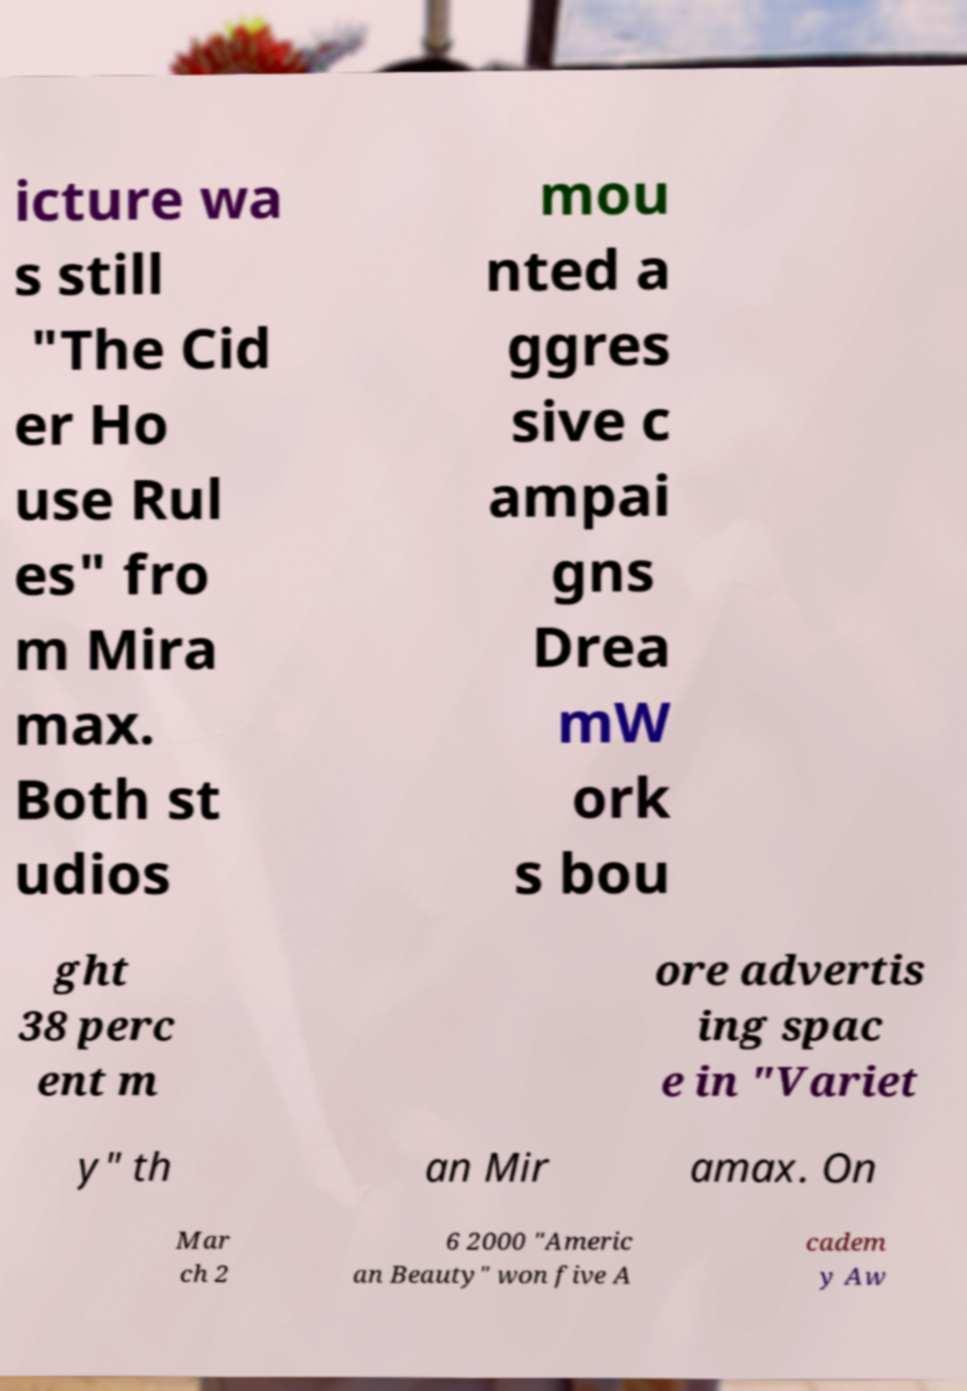What messages or text are displayed in this image? I need them in a readable, typed format. icture wa s still "The Cid er Ho use Rul es" fro m Mira max. Both st udios mou nted a ggres sive c ampai gns Drea mW ork s bou ght 38 perc ent m ore advertis ing spac e in "Variet y" th an Mir amax. On Mar ch 2 6 2000 "Americ an Beauty" won five A cadem y Aw 